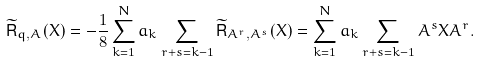Convert formula to latex. <formula><loc_0><loc_0><loc_500><loc_500>\widetilde { \mathsf R } _ { q , A } ( X ) = - \frac { 1 } { 8 } \sum _ { k = 1 } ^ { N } a _ { k } \sum _ { r + s = k - 1 } \widetilde { \mathsf R } _ { A ^ { r } , A ^ { s } } ( X ) = \sum _ { k = 1 } ^ { N } a _ { k } \sum _ { r + s = k - 1 } A ^ { s } X A ^ { r } .</formula> 